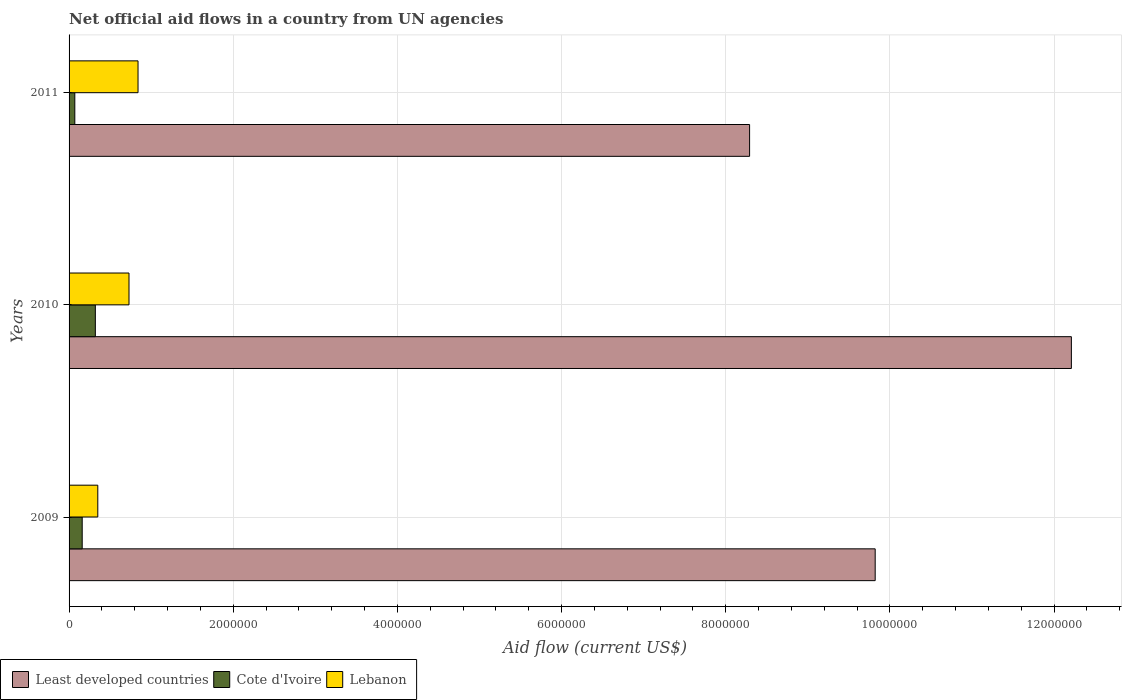How many different coloured bars are there?
Provide a short and direct response. 3. Are the number of bars per tick equal to the number of legend labels?
Your response must be concise. Yes. How many bars are there on the 2nd tick from the top?
Your answer should be very brief. 3. How many bars are there on the 3rd tick from the bottom?
Offer a terse response. 3. What is the net official aid flow in Least developed countries in 2011?
Offer a very short reply. 8.29e+06. Across all years, what is the maximum net official aid flow in Lebanon?
Provide a succinct answer. 8.40e+05. Across all years, what is the minimum net official aid flow in Lebanon?
Your response must be concise. 3.50e+05. In which year was the net official aid flow in Least developed countries maximum?
Keep it short and to the point. 2010. In which year was the net official aid flow in Least developed countries minimum?
Your answer should be very brief. 2011. What is the total net official aid flow in Least developed countries in the graph?
Provide a short and direct response. 3.03e+07. What is the difference between the net official aid flow in Cote d'Ivoire in 2009 and that in 2010?
Your response must be concise. -1.60e+05. What is the difference between the net official aid flow in Cote d'Ivoire in 2009 and the net official aid flow in Lebanon in 2011?
Make the answer very short. -6.80e+05. What is the average net official aid flow in Lebanon per year?
Your response must be concise. 6.40e+05. In the year 2010, what is the difference between the net official aid flow in Lebanon and net official aid flow in Cote d'Ivoire?
Make the answer very short. 4.10e+05. In how many years, is the net official aid flow in Lebanon greater than 7200000 US$?
Ensure brevity in your answer.  0. What is the ratio of the net official aid flow in Cote d'Ivoire in 2010 to that in 2011?
Offer a terse response. 4.57. What is the difference between the highest and the second highest net official aid flow in Least developed countries?
Your answer should be very brief. 2.39e+06. What is the difference between the highest and the lowest net official aid flow in Least developed countries?
Provide a succinct answer. 3.92e+06. In how many years, is the net official aid flow in Least developed countries greater than the average net official aid flow in Least developed countries taken over all years?
Give a very brief answer. 1. Is the sum of the net official aid flow in Cote d'Ivoire in 2009 and 2010 greater than the maximum net official aid flow in Lebanon across all years?
Ensure brevity in your answer.  No. What does the 1st bar from the top in 2010 represents?
Provide a short and direct response. Lebanon. What does the 1st bar from the bottom in 2010 represents?
Your answer should be compact. Least developed countries. What is the difference between two consecutive major ticks on the X-axis?
Make the answer very short. 2.00e+06. Where does the legend appear in the graph?
Give a very brief answer. Bottom left. How are the legend labels stacked?
Ensure brevity in your answer.  Horizontal. What is the title of the graph?
Ensure brevity in your answer.  Net official aid flows in a country from UN agencies. Does "Trinidad and Tobago" appear as one of the legend labels in the graph?
Ensure brevity in your answer.  No. What is the label or title of the Y-axis?
Your response must be concise. Years. What is the Aid flow (current US$) of Least developed countries in 2009?
Provide a succinct answer. 9.82e+06. What is the Aid flow (current US$) of Lebanon in 2009?
Your response must be concise. 3.50e+05. What is the Aid flow (current US$) in Least developed countries in 2010?
Keep it short and to the point. 1.22e+07. What is the Aid flow (current US$) in Cote d'Ivoire in 2010?
Keep it short and to the point. 3.20e+05. What is the Aid flow (current US$) in Lebanon in 2010?
Offer a very short reply. 7.30e+05. What is the Aid flow (current US$) in Least developed countries in 2011?
Keep it short and to the point. 8.29e+06. What is the Aid flow (current US$) in Cote d'Ivoire in 2011?
Give a very brief answer. 7.00e+04. What is the Aid flow (current US$) in Lebanon in 2011?
Give a very brief answer. 8.40e+05. Across all years, what is the maximum Aid flow (current US$) of Least developed countries?
Your answer should be compact. 1.22e+07. Across all years, what is the maximum Aid flow (current US$) of Cote d'Ivoire?
Ensure brevity in your answer.  3.20e+05. Across all years, what is the maximum Aid flow (current US$) in Lebanon?
Give a very brief answer. 8.40e+05. Across all years, what is the minimum Aid flow (current US$) in Least developed countries?
Give a very brief answer. 8.29e+06. Across all years, what is the minimum Aid flow (current US$) in Lebanon?
Make the answer very short. 3.50e+05. What is the total Aid flow (current US$) of Least developed countries in the graph?
Provide a short and direct response. 3.03e+07. What is the total Aid flow (current US$) in Lebanon in the graph?
Your answer should be very brief. 1.92e+06. What is the difference between the Aid flow (current US$) of Least developed countries in 2009 and that in 2010?
Give a very brief answer. -2.39e+06. What is the difference between the Aid flow (current US$) in Cote d'Ivoire in 2009 and that in 2010?
Keep it short and to the point. -1.60e+05. What is the difference between the Aid flow (current US$) in Lebanon in 2009 and that in 2010?
Give a very brief answer. -3.80e+05. What is the difference between the Aid flow (current US$) of Least developed countries in 2009 and that in 2011?
Keep it short and to the point. 1.53e+06. What is the difference between the Aid flow (current US$) in Cote d'Ivoire in 2009 and that in 2011?
Offer a terse response. 9.00e+04. What is the difference between the Aid flow (current US$) of Lebanon in 2009 and that in 2011?
Offer a very short reply. -4.90e+05. What is the difference between the Aid flow (current US$) of Least developed countries in 2010 and that in 2011?
Your answer should be very brief. 3.92e+06. What is the difference between the Aid flow (current US$) of Cote d'Ivoire in 2010 and that in 2011?
Provide a short and direct response. 2.50e+05. What is the difference between the Aid flow (current US$) of Lebanon in 2010 and that in 2011?
Offer a terse response. -1.10e+05. What is the difference between the Aid flow (current US$) in Least developed countries in 2009 and the Aid flow (current US$) in Cote d'Ivoire in 2010?
Ensure brevity in your answer.  9.50e+06. What is the difference between the Aid flow (current US$) in Least developed countries in 2009 and the Aid flow (current US$) in Lebanon in 2010?
Provide a succinct answer. 9.09e+06. What is the difference between the Aid flow (current US$) of Cote d'Ivoire in 2009 and the Aid flow (current US$) of Lebanon in 2010?
Ensure brevity in your answer.  -5.70e+05. What is the difference between the Aid flow (current US$) of Least developed countries in 2009 and the Aid flow (current US$) of Cote d'Ivoire in 2011?
Your answer should be very brief. 9.75e+06. What is the difference between the Aid flow (current US$) in Least developed countries in 2009 and the Aid flow (current US$) in Lebanon in 2011?
Offer a terse response. 8.98e+06. What is the difference between the Aid flow (current US$) in Cote d'Ivoire in 2009 and the Aid flow (current US$) in Lebanon in 2011?
Provide a succinct answer. -6.80e+05. What is the difference between the Aid flow (current US$) in Least developed countries in 2010 and the Aid flow (current US$) in Cote d'Ivoire in 2011?
Provide a short and direct response. 1.21e+07. What is the difference between the Aid flow (current US$) of Least developed countries in 2010 and the Aid flow (current US$) of Lebanon in 2011?
Offer a terse response. 1.14e+07. What is the difference between the Aid flow (current US$) of Cote d'Ivoire in 2010 and the Aid flow (current US$) of Lebanon in 2011?
Your response must be concise. -5.20e+05. What is the average Aid flow (current US$) of Least developed countries per year?
Your response must be concise. 1.01e+07. What is the average Aid flow (current US$) in Cote d'Ivoire per year?
Provide a short and direct response. 1.83e+05. What is the average Aid flow (current US$) of Lebanon per year?
Provide a short and direct response. 6.40e+05. In the year 2009, what is the difference between the Aid flow (current US$) of Least developed countries and Aid flow (current US$) of Cote d'Ivoire?
Keep it short and to the point. 9.66e+06. In the year 2009, what is the difference between the Aid flow (current US$) of Least developed countries and Aid flow (current US$) of Lebanon?
Offer a very short reply. 9.47e+06. In the year 2010, what is the difference between the Aid flow (current US$) of Least developed countries and Aid flow (current US$) of Cote d'Ivoire?
Ensure brevity in your answer.  1.19e+07. In the year 2010, what is the difference between the Aid flow (current US$) of Least developed countries and Aid flow (current US$) of Lebanon?
Offer a terse response. 1.15e+07. In the year 2010, what is the difference between the Aid flow (current US$) of Cote d'Ivoire and Aid flow (current US$) of Lebanon?
Your answer should be very brief. -4.10e+05. In the year 2011, what is the difference between the Aid flow (current US$) in Least developed countries and Aid flow (current US$) in Cote d'Ivoire?
Provide a short and direct response. 8.22e+06. In the year 2011, what is the difference between the Aid flow (current US$) in Least developed countries and Aid flow (current US$) in Lebanon?
Your answer should be compact. 7.45e+06. In the year 2011, what is the difference between the Aid flow (current US$) of Cote d'Ivoire and Aid flow (current US$) of Lebanon?
Provide a succinct answer. -7.70e+05. What is the ratio of the Aid flow (current US$) of Least developed countries in 2009 to that in 2010?
Keep it short and to the point. 0.8. What is the ratio of the Aid flow (current US$) in Cote d'Ivoire in 2009 to that in 2010?
Offer a terse response. 0.5. What is the ratio of the Aid flow (current US$) of Lebanon in 2009 to that in 2010?
Your answer should be very brief. 0.48. What is the ratio of the Aid flow (current US$) in Least developed countries in 2009 to that in 2011?
Offer a terse response. 1.18. What is the ratio of the Aid flow (current US$) in Cote d'Ivoire in 2009 to that in 2011?
Ensure brevity in your answer.  2.29. What is the ratio of the Aid flow (current US$) in Lebanon in 2009 to that in 2011?
Your response must be concise. 0.42. What is the ratio of the Aid flow (current US$) in Least developed countries in 2010 to that in 2011?
Your answer should be compact. 1.47. What is the ratio of the Aid flow (current US$) of Cote d'Ivoire in 2010 to that in 2011?
Make the answer very short. 4.57. What is the ratio of the Aid flow (current US$) in Lebanon in 2010 to that in 2011?
Provide a succinct answer. 0.87. What is the difference between the highest and the second highest Aid flow (current US$) in Least developed countries?
Make the answer very short. 2.39e+06. What is the difference between the highest and the second highest Aid flow (current US$) of Lebanon?
Offer a very short reply. 1.10e+05. What is the difference between the highest and the lowest Aid flow (current US$) of Least developed countries?
Offer a very short reply. 3.92e+06. What is the difference between the highest and the lowest Aid flow (current US$) of Lebanon?
Provide a succinct answer. 4.90e+05. 